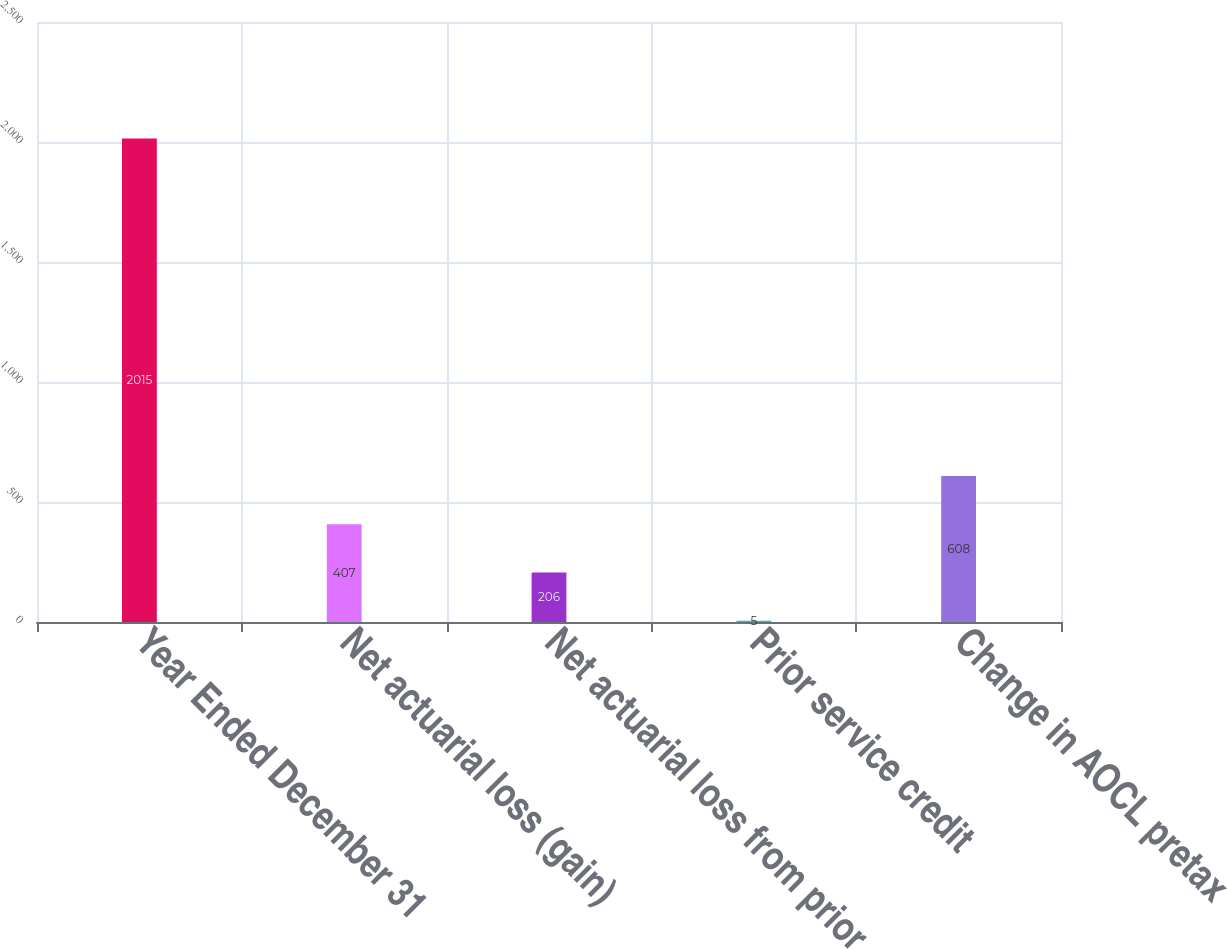Convert chart. <chart><loc_0><loc_0><loc_500><loc_500><bar_chart><fcel>Year Ended December 31<fcel>Net actuarial loss (gain)<fcel>Net actuarial loss from prior<fcel>Prior service credit<fcel>Change in AOCL pretax<nl><fcel>2015<fcel>407<fcel>206<fcel>5<fcel>608<nl></chart> 